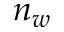Convert formula to latex. <formula><loc_0><loc_0><loc_500><loc_500>n _ { w }</formula> 